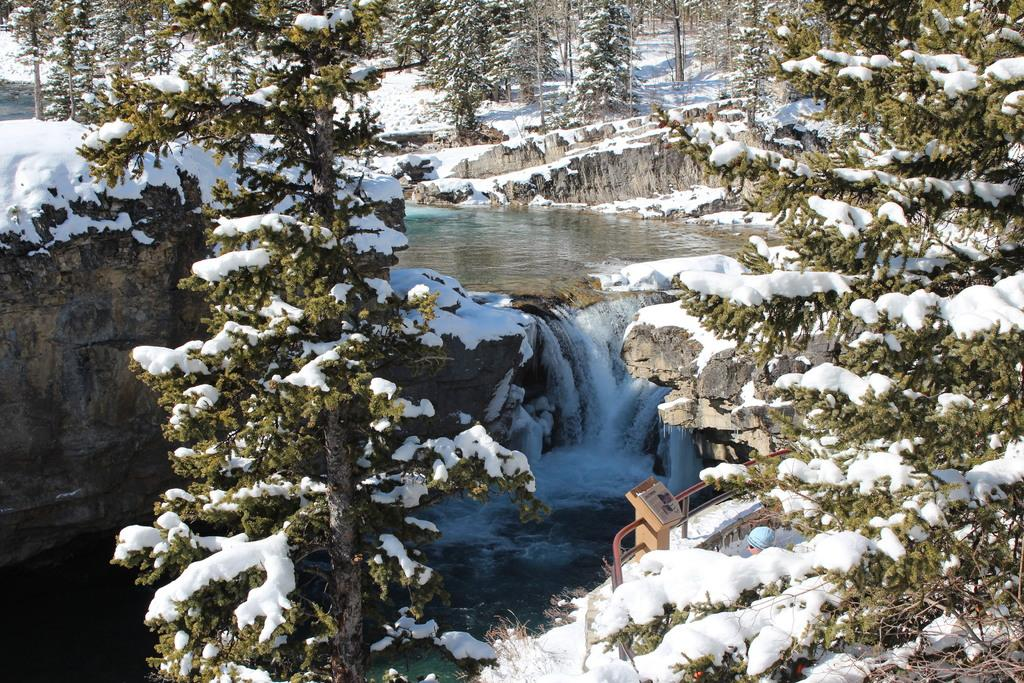What type of structure can be seen in the image? There is a railing in the image. What natural element is visible in the image? Water is visible in the image. What type of weather is suggested by the presence of snow in the image? Snow is present on the trees, rocks, and surface, suggesting cold weather. What type of bread can be seen in the image? There is no bread present in the image. Is there a mine visible in the image? There is no mine present in the image. 